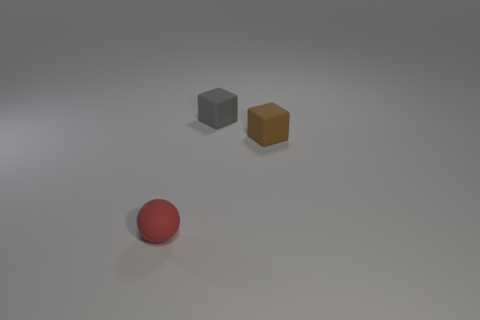If these objects were to symbolize concepts, what might they represent? The red sphere might symbolize unity or singularity due to its shape; the grey cube could stand for stability and strength, and the brown cube might represent solidity but with a natural or earthly aspect due to its color. 